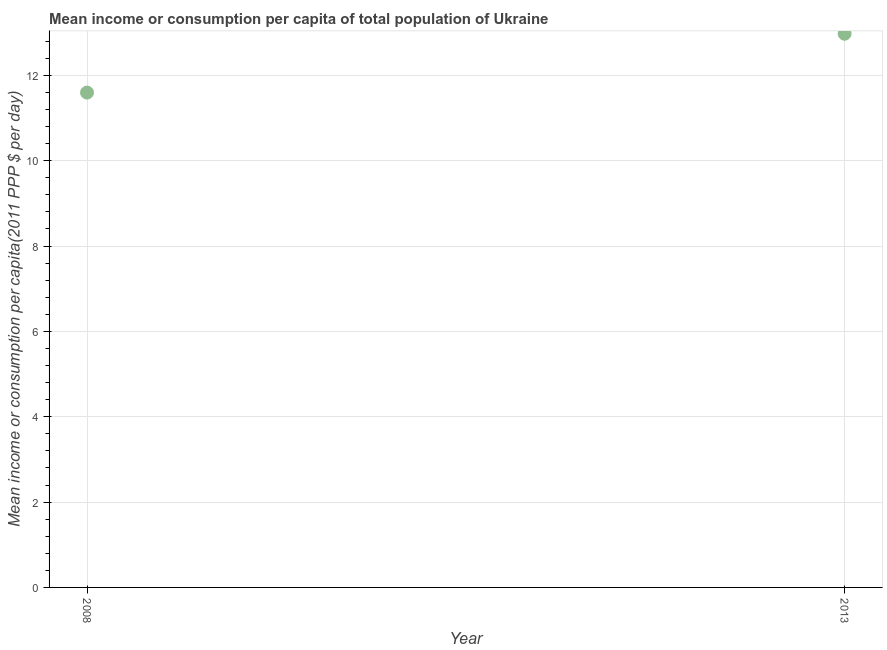What is the mean income or consumption in 2013?
Give a very brief answer. 12.97. Across all years, what is the maximum mean income or consumption?
Provide a succinct answer. 12.97. Across all years, what is the minimum mean income or consumption?
Ensure brevity in your answer.  11.6. What is the sum of the mean income or consumption?
Your response must be concise. 24.57. What is the difference between the mean income or consumption in 2008 and 2013?
Keep it short and to the point. -1.38. What is the average mean income or consumption per year?
Provide a short and direct response. 12.29. What is the median mean income or consumption?
Keep it short and to the point. 12.29. Do a majority of the years between 2013 and 2008 (inclusive) have mean income or consumption greater than 8.4 $?
Ensure brevity in your answer.  No. What is the ratio of the mean income or consumption in 2008 to that in 2013?
Keep it short and to the point. 0.89. In how many years, is the mean income or consumption greater than the average mean income or consumption taken over all years?
Keep it short and to the point. 1. How many dotlines are there?
Offer a very short reply. 1. How many years are there in the graph?
Offer a terse response. 2. What is the difference between two consecutive major ticks on the Y-axis?
Your response must be concise. 2. Does the graph contain any zero values?
Offer a terse response. No. What is the title of the graph?
Offer a very short reply. Mean income or consumption per capita of total population of Ukraine. What is the label or title of the Y-axis?
Your response must be concise. Mean income or consumption per capita(2011 PPP $ per day). What is the Mean income or consumption per capita(2011 PPP $ per day) in 2008?
Give a very brief answer. 11.6. What is the Mean income or consumption per capita(2011 PPP $ per day) in 2013?
Offer a very short reply. 12.97. What is the difference between the Mean income or consumption per capita(2011 PPP $ per day) in 2008 and 2013?
Offer a very short reply. -1.38. What is the ratio of the Mean income or consumption per capita(2011 PPP $ per day) in 2008 to that in 2013?
Provide a short and direct response. 0.89. 